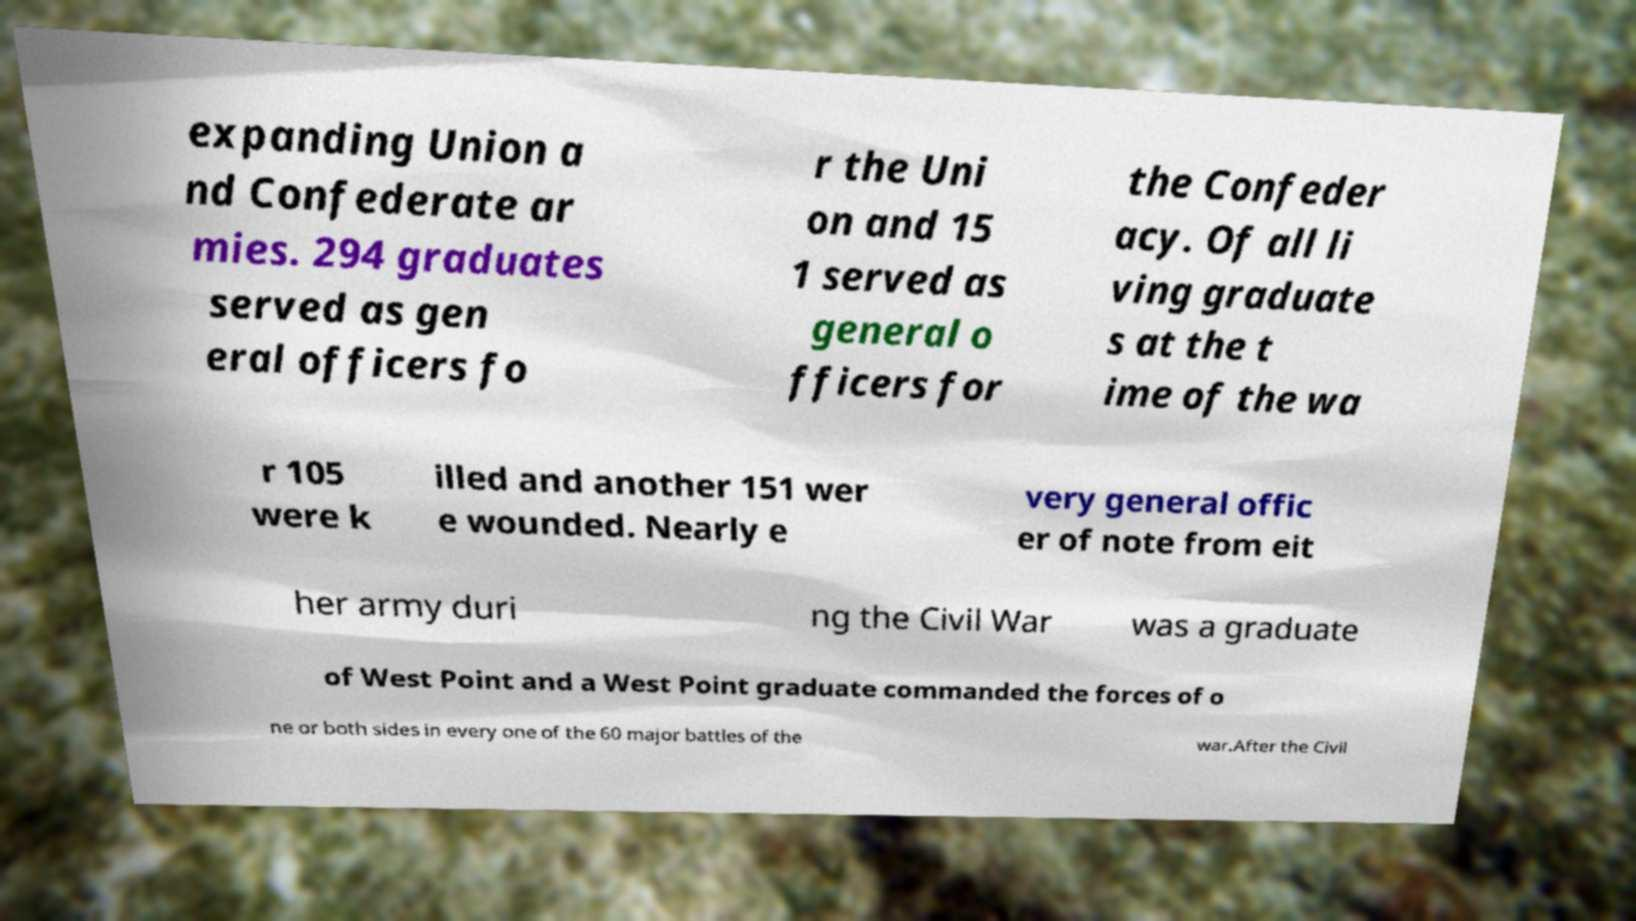Could you assist in decoding the text presented in this image and type it out clearly? expanding Union a nd Confederate ar mies. 294 graduates served as gen eral officers fo r the Uni on and 15 1 served as general o fficers for the Confeder acy. Of all li ving graduate s at the t ime of the wa r 105 were k illed and another 151 wer e wounded. Nearly e very general offic er of note from eit her army duri ng the Civil War was a graduate of West Point and a West Point graduate commanded the forces of o ne or both sides in every one of the 60 major battles of the war.After the Civil 